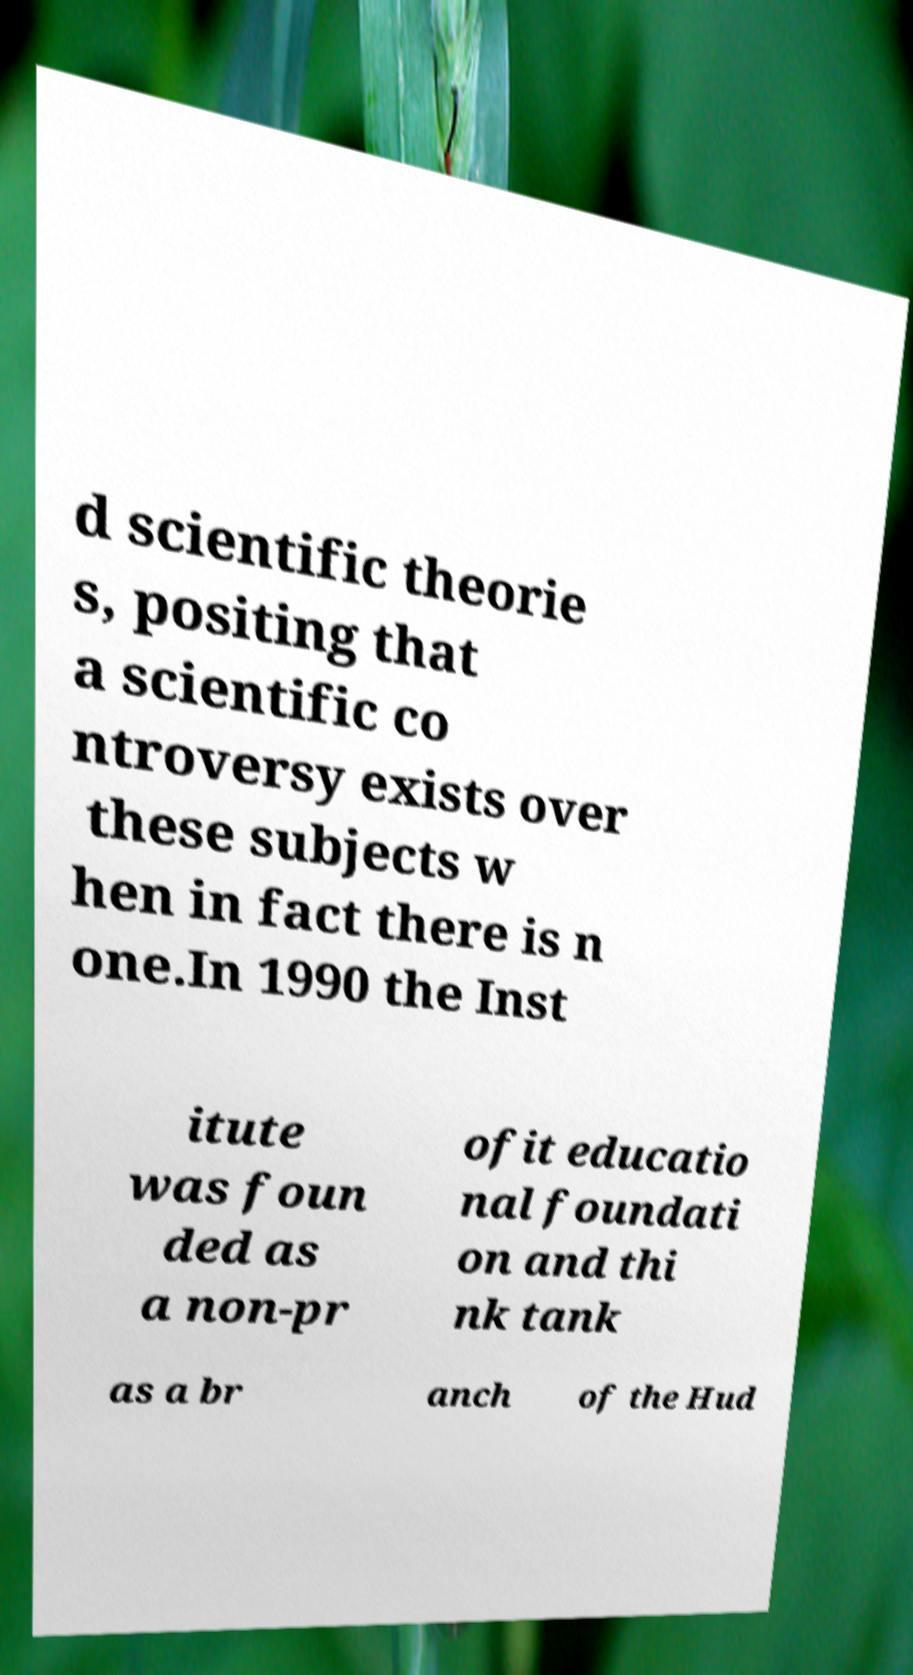There's text embedded in this image that I need extracted. Can you transcribe it verbatim? d scientific theorie s, positing that a scientific co ntroversy exists over these subjects w hen in fact there is n one.In 1990 the Inst itute was foun ded as a non-pr ofit educatio nal foundati on and thi nk tank as a br anch of the Hud 